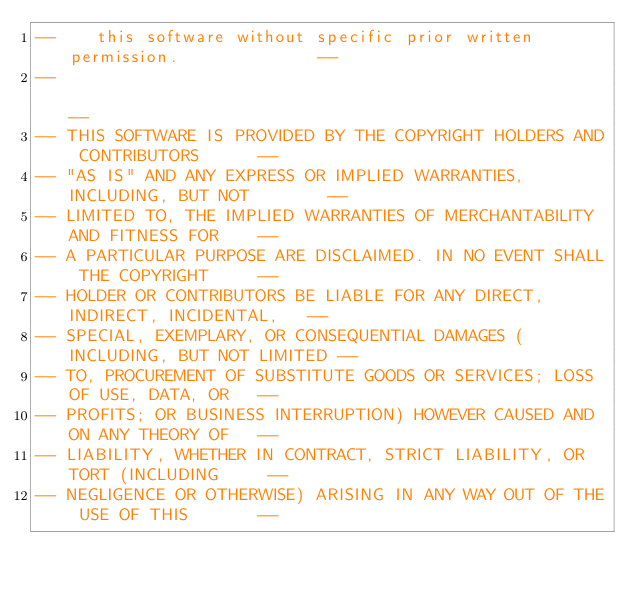<code> <loc_0><loc_0><loc_500><loc_500><_Ada_>--    this software without specific prior written permission.              --
--                                                                          --
-- THIS SOFTWARE IS PROVIDED BY THE COPYRIGHT HOLDERS AND CONTRIBUTORS      --
-- "AS IS" AND ANY EXPRESS OR IMPLIED WARRANTIES, INCLUDING, BUT NOT        --
-- LIMITED TO, THE IMPLIED WARRANTIES OF MERCHANTABILITY AND FITNESS FOR    --
-- A PARTICULAR PURPOSE ARE DISCLAIMED. IN NO EVENT SHALL THE COPYRIGHT     --
-- HOLDER OR CONTRIBUTORS BE LIABLE FOR ANY DIRECT, INDIRECT, INCIDENTAL,   --
-- SPECIAL, EXEMPLARY, OR CONSEQUENTIAL DAMAGES (INCLUDING, BUT NOT LIMITED --
-- TO, PROCUREMENT OF SUBSTITUTE GOODS OR SERVICES; LOSS OF USE, DATA, OR   --
-- PROFITS; OR BUSINESS INTERRUPTION) HOWEVER CAUSED AND ON ANY THEORY OF   --
-- LIABILITY, WHETHER IN CONTRACT, STRICT LIABILITY, OR TORT (INCLUDING     --
-- NEGLIGENCE OR OTHERWISE) ARISING IN ANY WAY OUT OF THE USE OF THIS       --</code> 